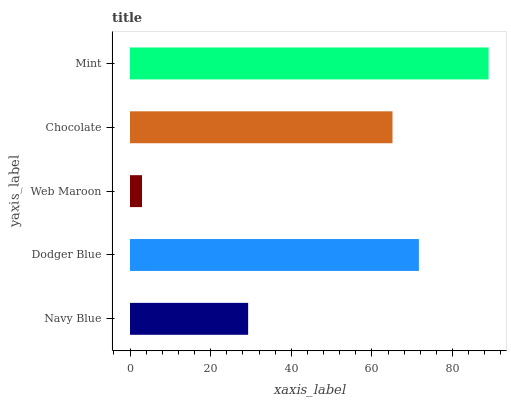Is Web Maroon the minimum?
Answer yes or no. Yes. Is Mint the maximum?
Answer yes or no. Yes. Is Dodger Blue the minimum?
Answer yes or no. No. Is Dodger Blue the maximum?
Answer yes or no. No. Is Dodger Blue greater than Navy Blue?
Answer yes or no. Yes. Is Navy Blue less than Dodger Blue?
Answer yes or no. Yes. Is Navy Blue greater than Dodger Blue?
Answer yes or no. No. Is Dodger Blue less than Navy Blue?
Answer yes or no. No. Is Chocolate the high median?
Answer yes or no. Yes. Is Chocolate the low median?
Answer yes or no. Yes. Is Dodger Blue the high median?
Answer yes or no. No. Is Navy Blue the low median?
Answer yes or no. No. 